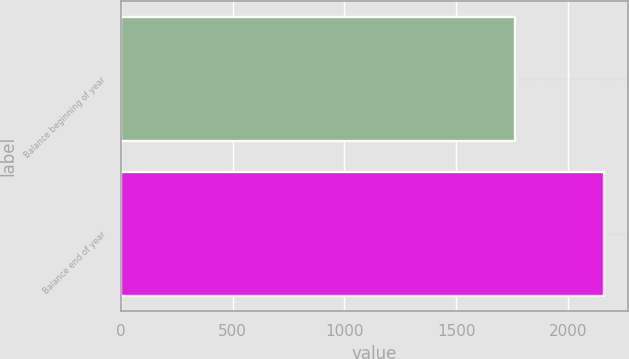Convert chart to OTSL. <chart><loc_0><loc_0><loc_500><loc_500><bar_chart><fcel>Balance beginning of year<fcel>Balance end of year<nl><fcel>1764<fcel>2162<nl></chart> 